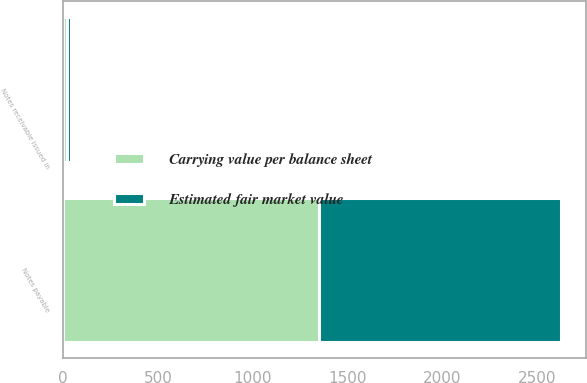<chart> <loc_0><loc_0><loc_500><loc_500><stacked_bar_chart><ecel><fcel>Notes receivable issued in<fcel>Notes payable<nl><fcel>Carrying value per balance sheet<fcel>22.2<fcel>1350<nl><fcel>Estimated fair market value<fcel>20<fcel>1276.4<nl></chart> 